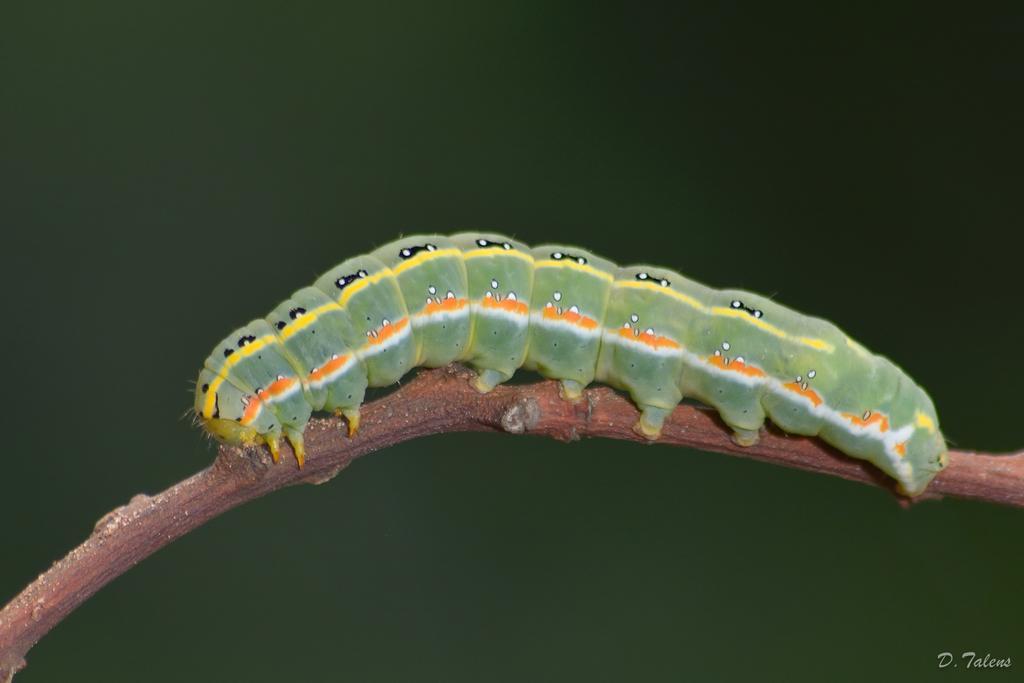Can you describe this image briefly? In this picture there is a caterpillar on the stem. At the back there is a green color background. At the bottom right there is text. 